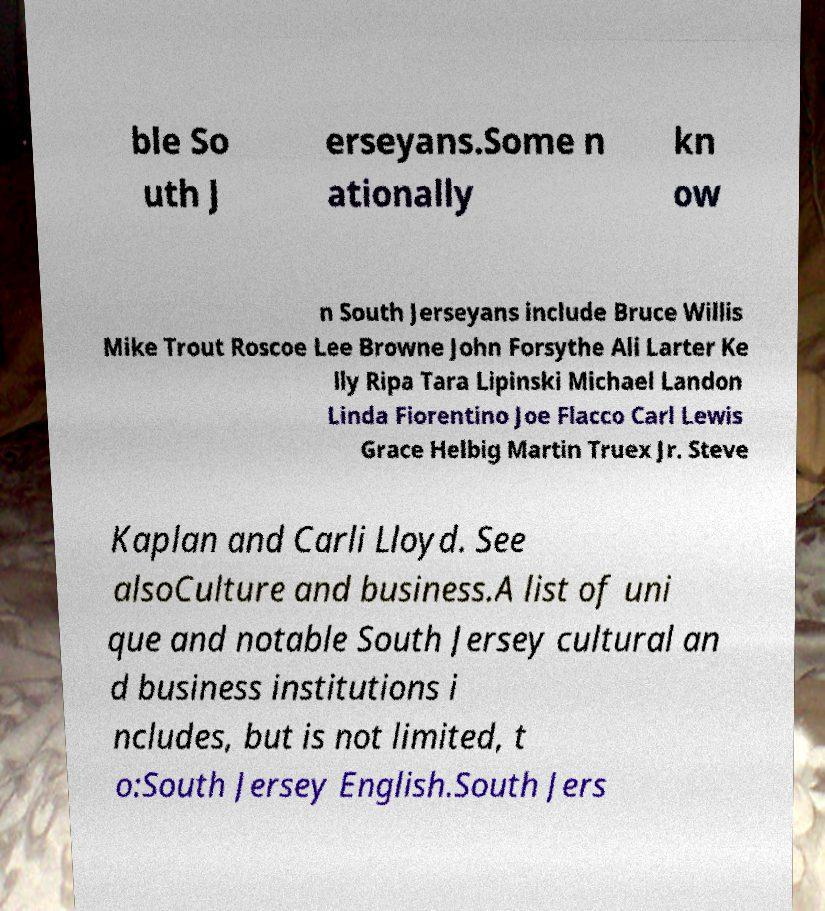There's text embedded in this image that I need extracted. Can you transcribe it verbatim? ble So uth J erseyans.Some n ationally kn ow n South Jerseyans include Bruce Willis Mike Trout Roscoe Lee Browne John Forsythe Ali Larter Ke lly Ripa Tara Lipinski Michael Landon Linda Fiorentino Joe Flacco Carl Lewis Grace Helbig Martin Truex Jr. Steve Kaplan and Carli Lloyd. See alsoCulture and business.A list of uni que and notable South Jersey cultural an d business institutions i ncludes, but is not limited, t o:South Jersey English.South Jers 